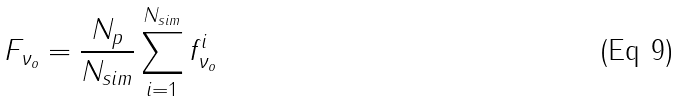Convert formula to latex. <formula><loc_0><loc_0><loc_500><loc_500>F _ { \nu _ { o } } = \frac { N _ { p } } { N _ { s i m } } \sum _ { i = 1 } ^ { N _ { s i m } } f _ { \nu _ { o } } ^ { i }</formula> 